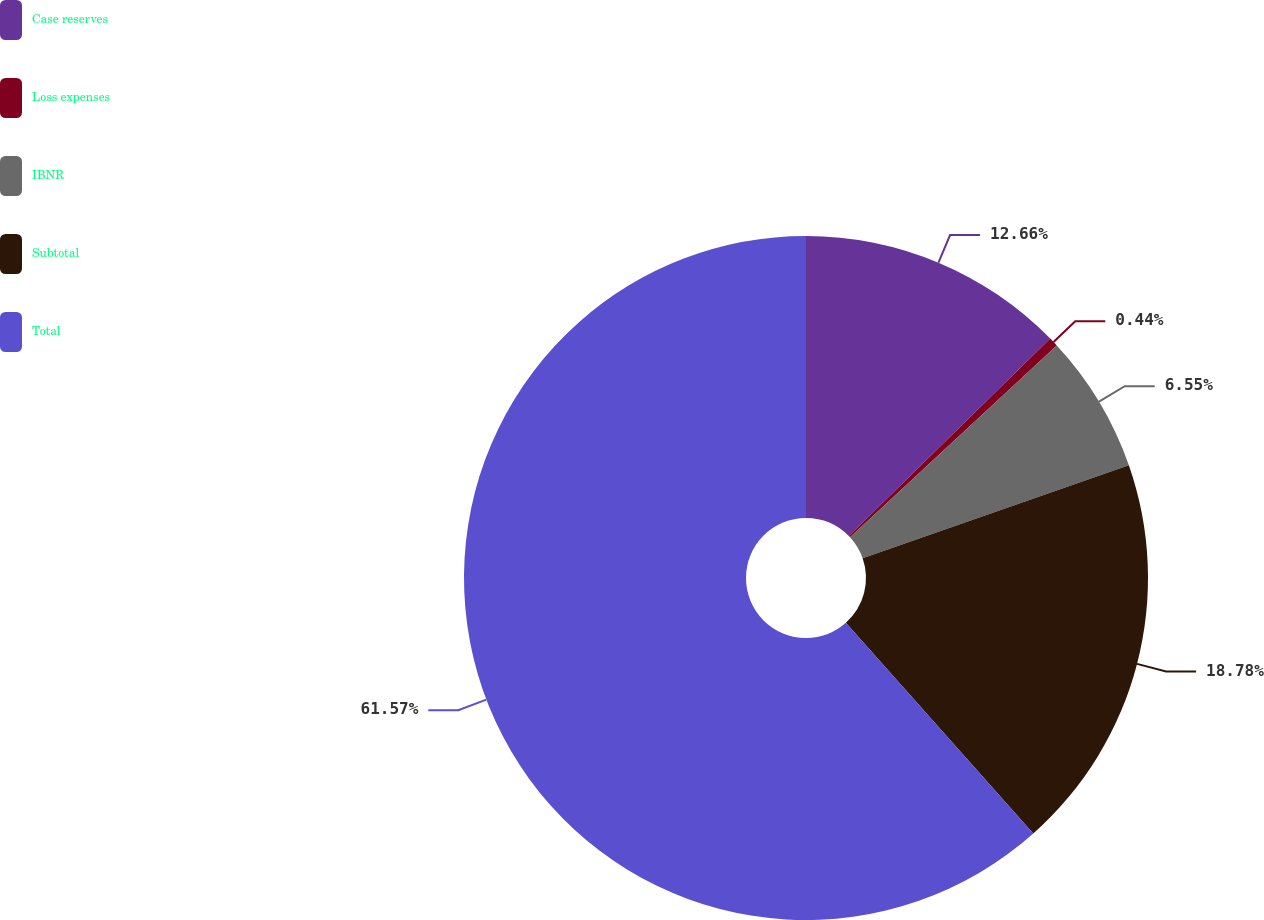Convert chart. <chart><loc_0><loc_0><loc_500><loc_500><pie_chart><fcel>Case reserves<fcel>Loss expenses<fcel>IBNR<fcel>Subtotal<fcel>Total<nl><fcel>12.66%<fcel>0.44%<fcel>6.55%<fcel>18.78%<fcel>61.57%<nl></chart> 